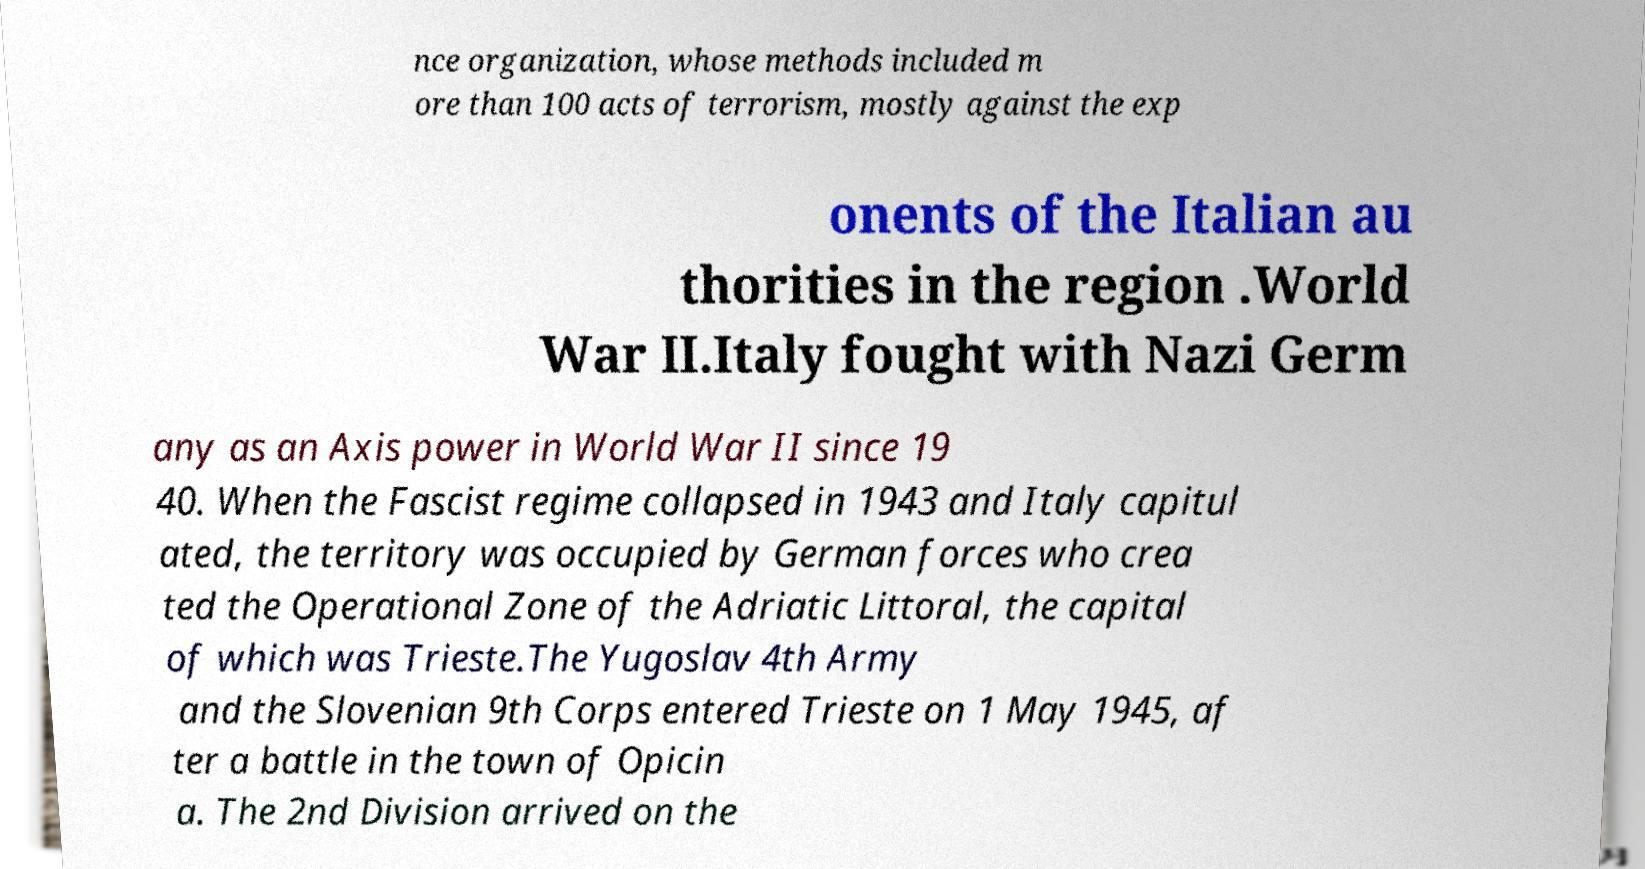Could you assist in decoding the text presented in this image and type it out clearly? nce organization, whose methods included m ore than 100 acts of terrorism, mostly against the exp onents of the Italian au thorities in the region .World War II.Italy fought with Nazi Germ any as an Axis power in World War II since 19 40. When the Fascist regime collapsed in 1943 and Italy capitul ated, the territory was occupied by German forces who crea ted the Operational Zone of the Adriatic Littoral, the capital of which was Trieste.The Yugoslav 4th Army and the Slovenian 9th Corps entered Trieste on 1 May 1945, af ter a battle in the town of Opicin a. The 2nd Division arrived on the 